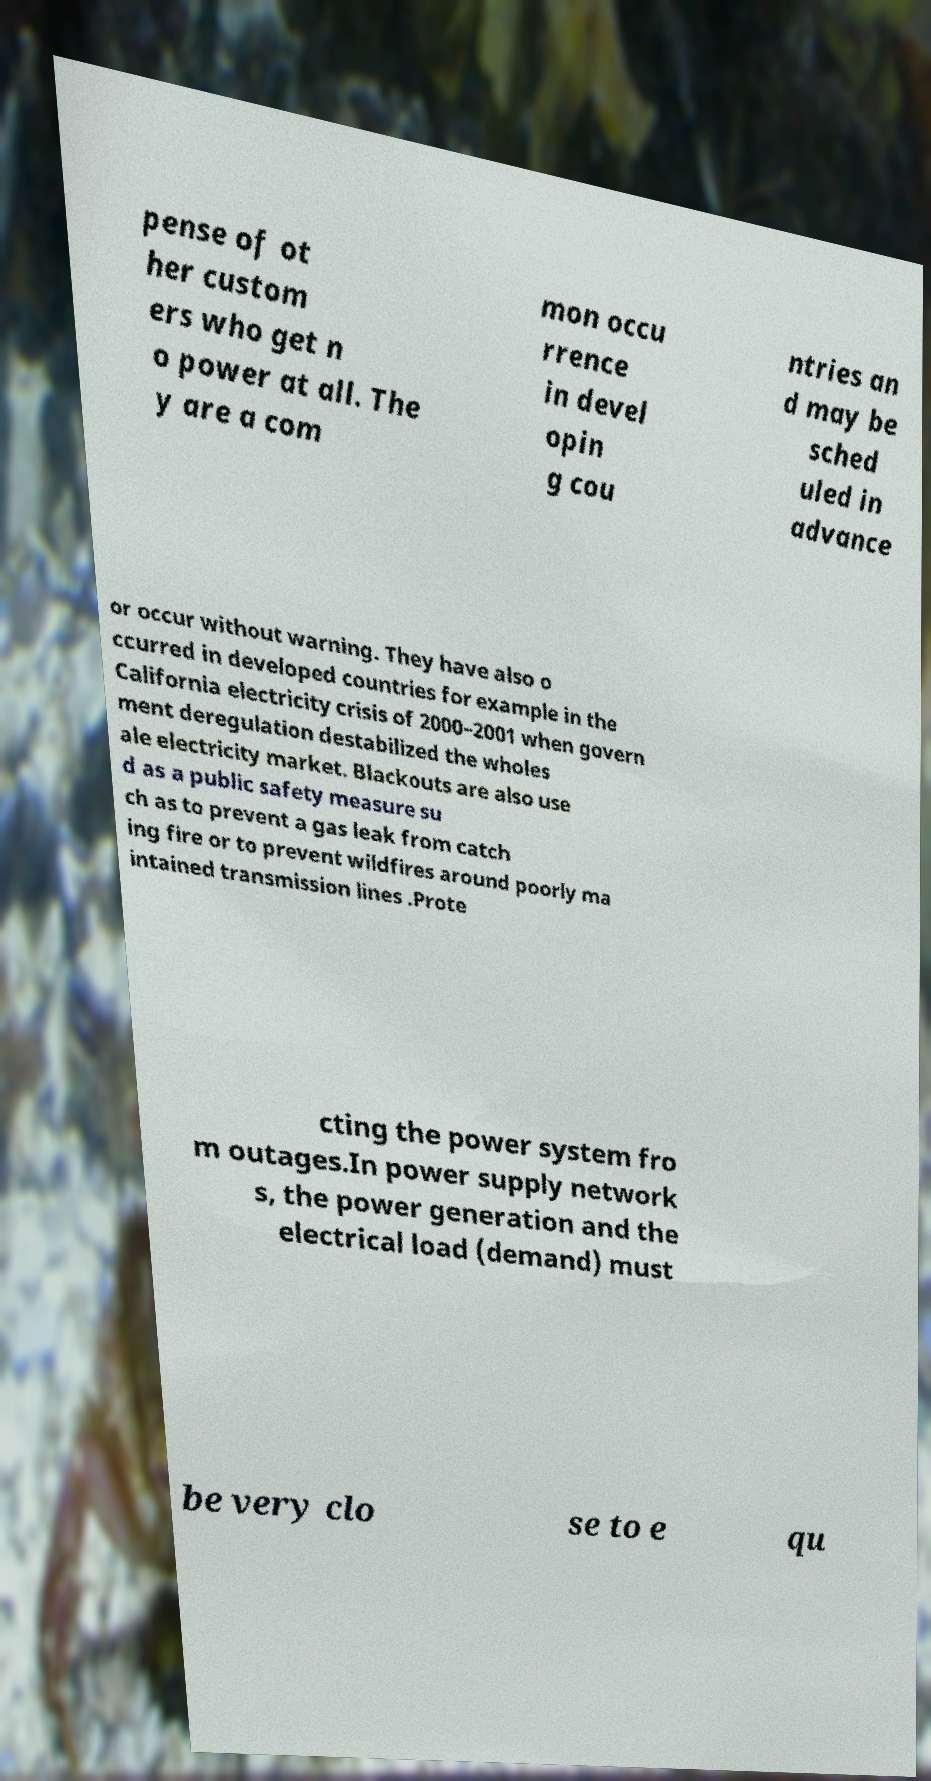Can you read and provide the text displayed in the image?This photo seems to have some interesting text. Can you extract and type it out for me? pense of ot her custom ers who get n o power at all. The y are a com mon occu rrence in devel opin g cou ntries an d may be sched uled in advance or occur without warning. They have also o ccurred in developed countries for example in the California electricity crisis of 2000–2001 when govern ment deregulation destabilized the wholes ale electricity market. Blackouts are also use d as a public safety measure su ch as to prevent a gas leak from catch ing fire or to prevent wildfires around poorly ma intained transmission lines .Prote cting the power system fro m outages.In power supply network s, the power generation and the electrical load (demand) must be very clo se to e qu 